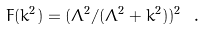Convert formula to latex. <formula><loc_0><loc_0><loc_500><loc_500>F ( k ^ { 2 } ) = ( \Lambda ^ { 2 } / ( \Lambda ^ { 2 } + k ^ { 2 } ) ) ^ { 2 } \ .</formula> 